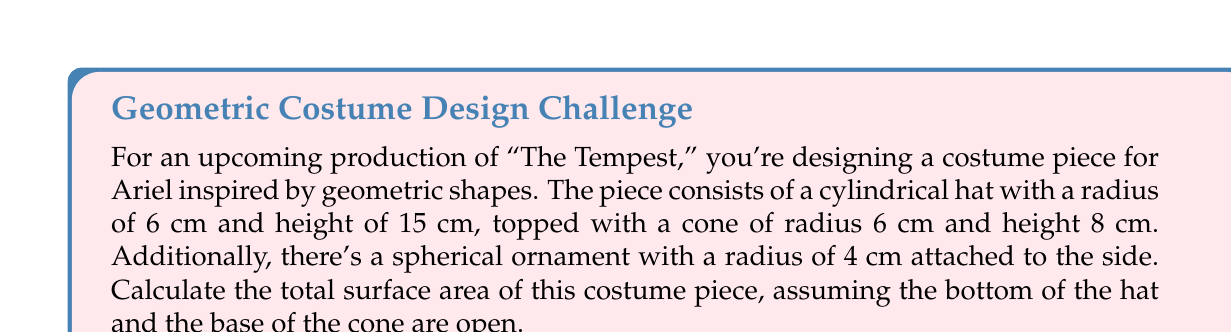Help me with this question. Let's break this down step-by-step:

1) For the cylindrical hat:
   Surface area = Lateral surface area (no bottom)
   $$ SA_{cylinder} = 2\pi rh $$
   $$ SA_{cylinder} = 2\pi(6)(15) = 180\pi \text{ cm}^2 $$

2) For the conical top:
   Surface area = Lateral surface area (no base)
   $$ SA_{cone} = \pi rs $$
   where $s$ is the slant height. We can find $s$ using the Pythagorean theorem:
   $$ s = \sqrt{r^2 + h^2} = \sqrt{6^2 + 8^2} = \sqrt{36 + 64} = \sqrt{100} = 10 \text{ cm} $$
   $$ SA_{cone} = \pi(6)(10) = 60\pi \text{ cm}^2 $$

3) For the spherical ornament:
   Surface area = Surface area of a sphere
   $$ SA_{sphere} = 4\pi r^2 $$
   $$ SA_{sphere} = 4\pi(4^2) = 64\pi \text{ cm}^2 $$

4) Total surface area:
   $$ SA_{total} = SA_{cylinder} + SA_{cone} + SA_{sphere} $$
   $$ SA_{total} = 180\pi + 60\pi + 64\pi = 304\pi \text{ cm}^2 $$
Answer: $304\pi \text{ cm}^2$ 